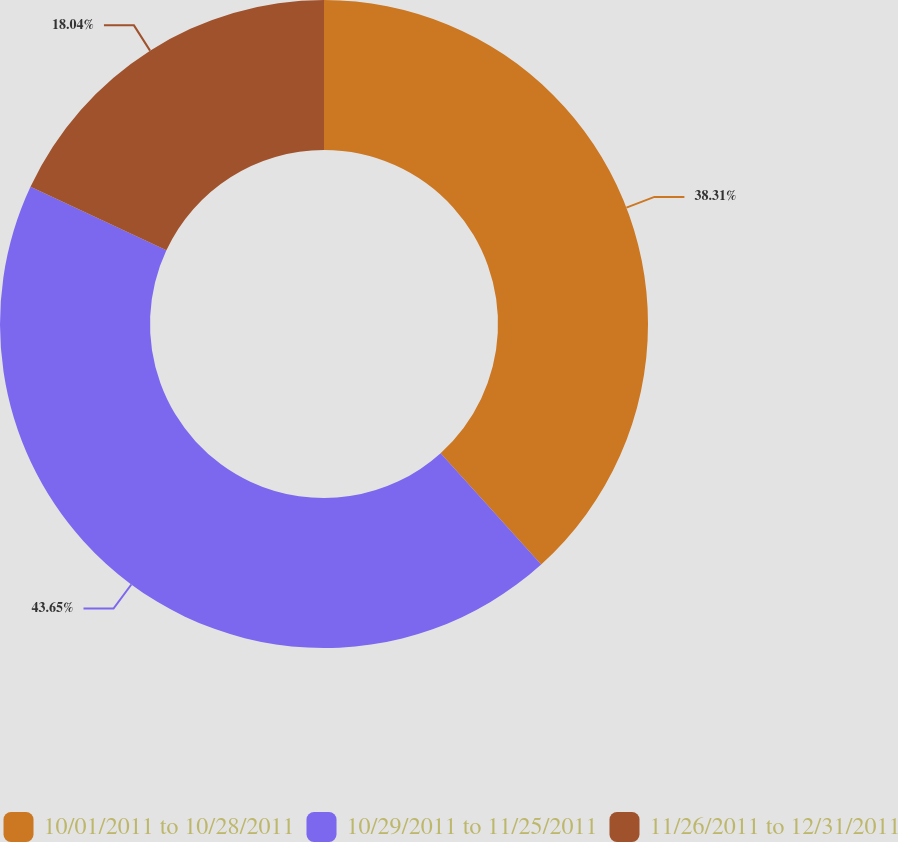<chart> <loc_0><loc_0><loc_500><loc_500><pie_chart><fcel>10/01/2011 to 10/28/2011<fcel>10/29/2011 to 11/25/2011<fcel>11/26/2011 to 12/31/2011<nl><fcel>38.31%<fcel>43.65%<fcel>18.04%<nl></chart> 